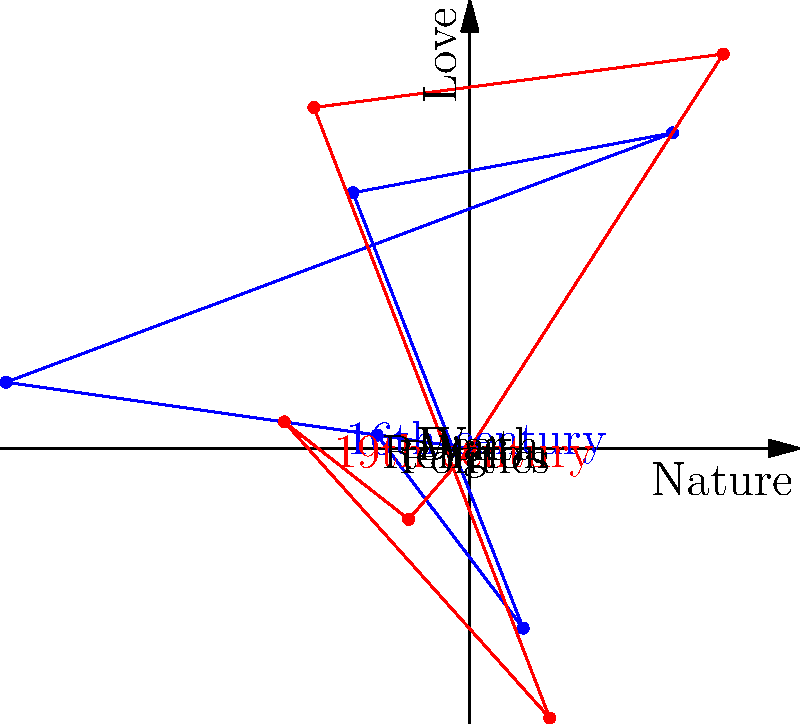Based on the rose diagram comparing thematic elements in poetry from the 16th and 19th centuries, which theme shows the most significant shift in prominence between these two periods? To answer this question, we need to analyze the rose diagram carefully:

1. The blue diagram represents the 16th century, while the red diagram represents the 19th century.

2. Each axis of the diagram represents a different theme:
   - Positive x-axis: Nature
   - Positive y-axis: Love
   - Negative x-axis: Religion
   - Negative y-axis: Politics
   - Upper-left: War
   - Upper-right: Death

3. We need to compare the length of each axis between the two centuries:

   - Nature: Slightly decreased from 16th to 19th century
   - Love: Increased from 16th to 19th century
   - Religion: Decreased from 16th to 19th century
   - Politics: Increased significantly from 16th to 19th century
   - War: Decreased from 16th to 19th century
   - Death: Remained relatively similar

4. The most significant shift is observed in the Politics theme, which shows a substantial increase from the 16th to the 19th century.

This shift in political themes aligns with historical events such as the American and French Revolutions, as well as the rise of nationalism and social reform movements in the 19th century, which likely influenced the poetic discourse of the time.
Answer: Politics 